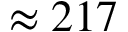<formula> <loc_0><loc_0><loc_500><loc_500>\approx 2 1 7</formula> 